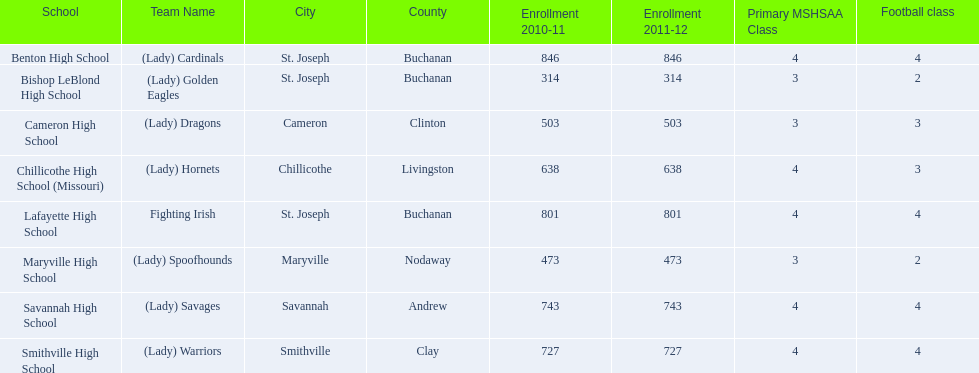What school in midland empire conference has 846 students enrolled? Benton High School. What school has 314 students enrolled? Bishop LeBlond High School. What school had 638 students enrolled? Chillicothe High School (Missouri). 